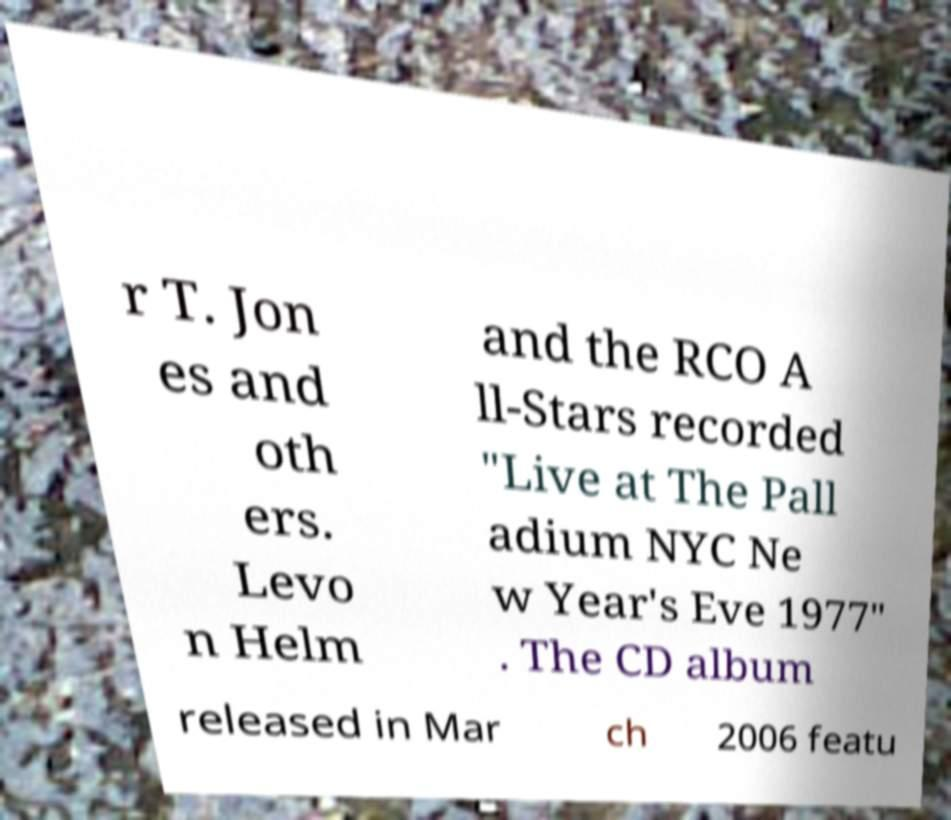Can you read and provide the text displayed in the image?This photo seems to have some interesting text. Can you extract and type it out for me? r T. Jon es and oth ers. Levo n Helm and the RCO A ll-Stars recorded "Live at The Pall adium NYC Ne w Year's Eve 1977" . The CD album released in Mar ch 2006 featu 